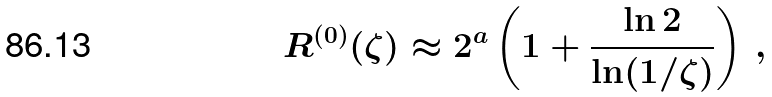Convert formula to latex. <formula><loc_0><loc_0><loc_500><loc_500>R ^ { ( 0 ) } ( \zeta ) \approx 2 ^ { a } \left ( 1 + \frac { \ln 2 } { \ln ( 1 / \zeta ) } \right ) \, ,</formula> 